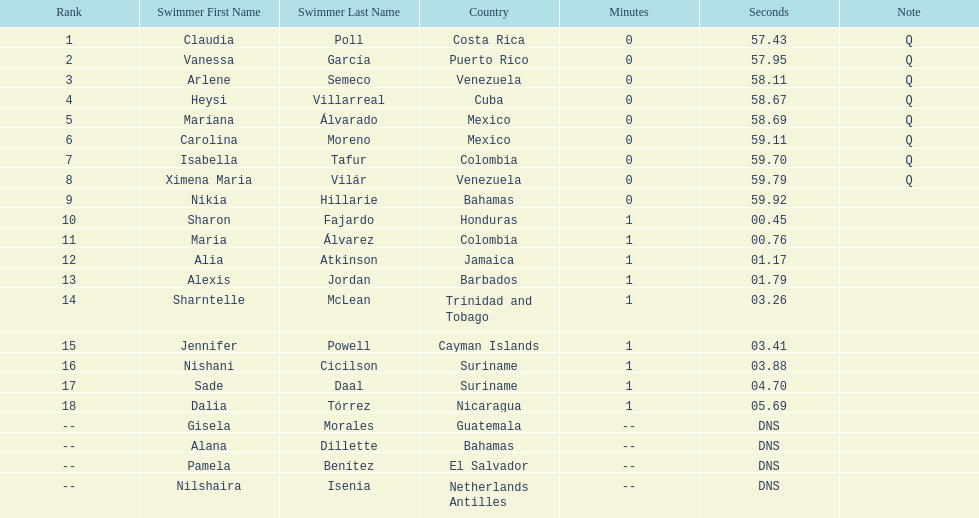How many competitors from venezuela qualified for the final? 2. 